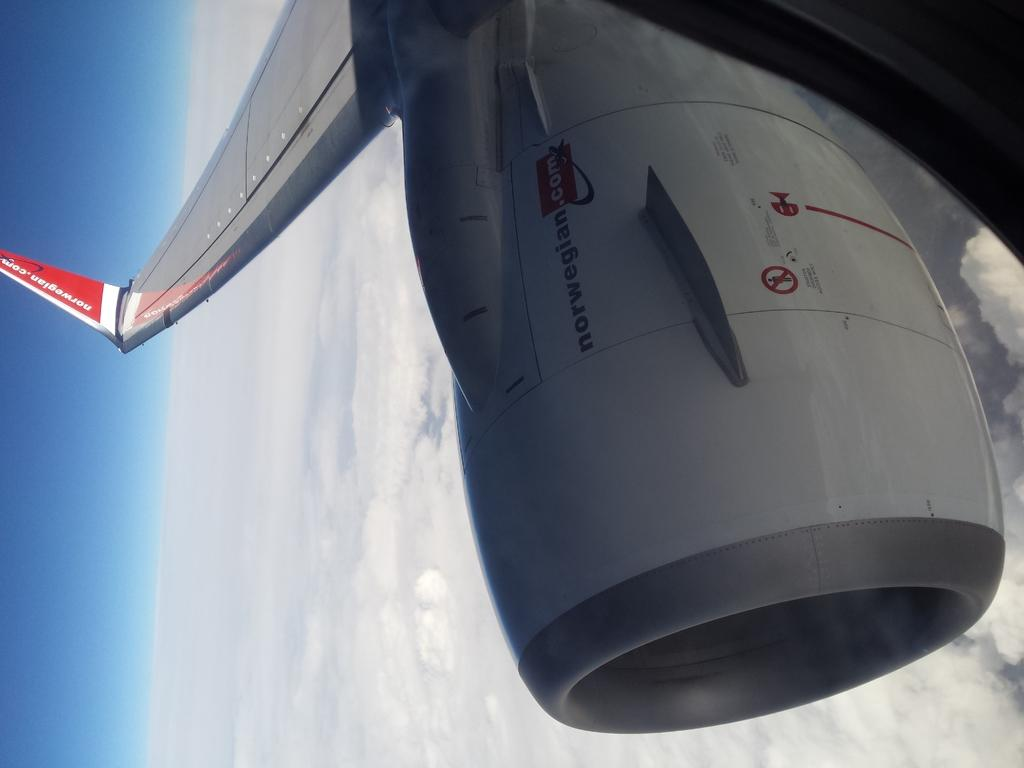<image>
Provide a brief description of the given image. A jet engine high in the sky advertises norwegian.com 